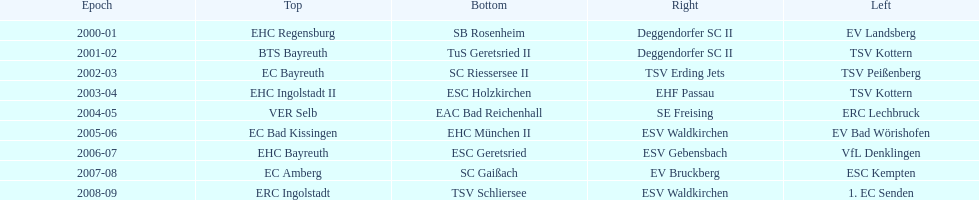Who won the south after esc geretsried did during the 2006-07 season? SC Gaißach. 